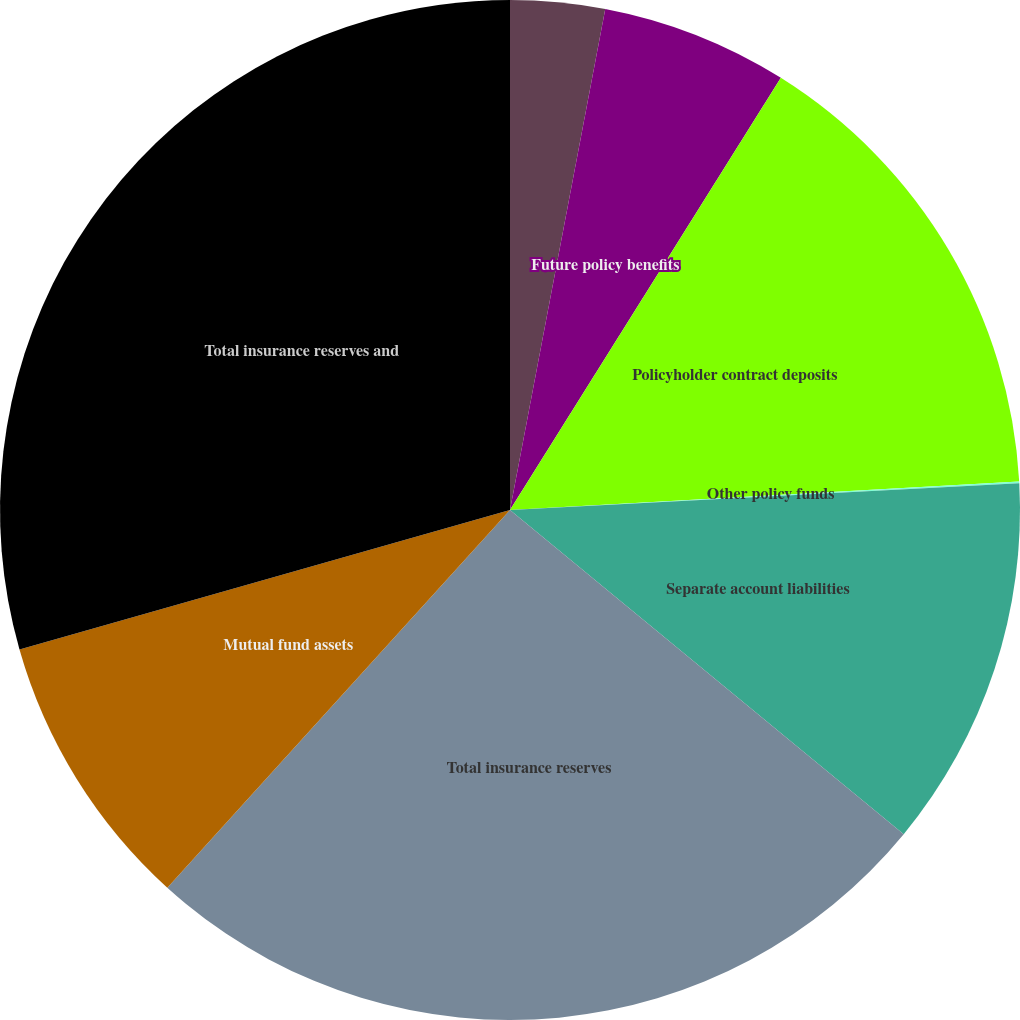<chart> <loc_0><loc_0><loc_500><loc_500><pie_chart><fcel>At December 31 (in millions)<fcel>Future policy benefits<fcel>Policyholder contract deposits<fcel>Other policy funds<fcel>Separate account liabilities<fcel>Total insurance reserves<fcel>Mutual fund assets<fcel>Total insurance reserves and<nl><fcel>2.99%<fcel>5.92%<fcel>15.2%<fcel>0.05%<fcel>11.8%<fcel>25.76%<fcel>8.86%<fcel>29.41%<nl></chart> 